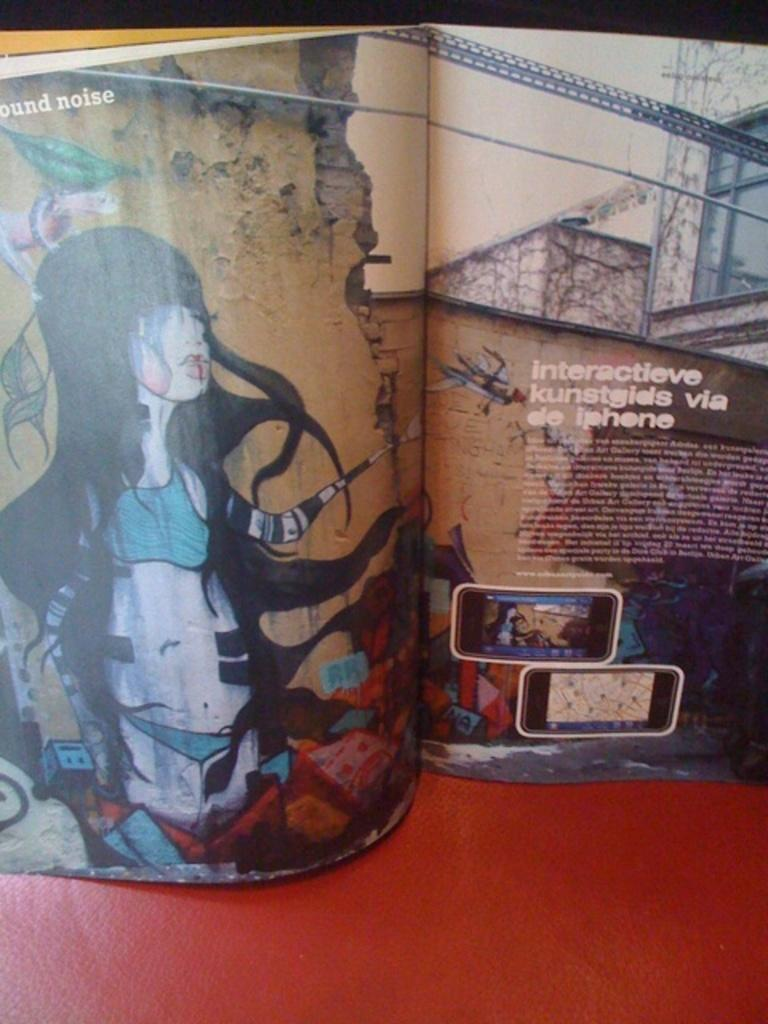What object is present in the image? There is a book in the image. What can be found inside the book? A person is depicted in the book, and there is text visible in the book. What type of flesh can be seen in the image? There is no flesh present in the image; it features a book with a person depicted and visible text. 